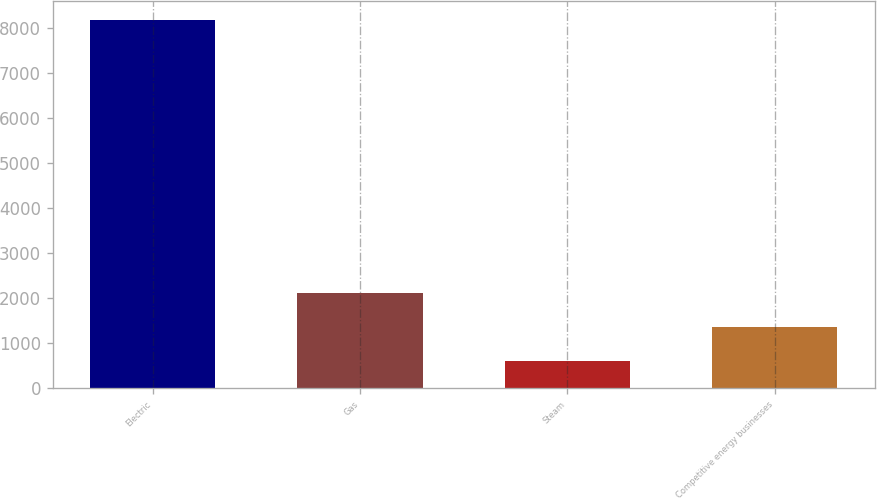<chart> <loc_0><loc_0><loc_500><loc_500><bar_chart><fcel>Electric<fcel>Gas<fcel>Steam<fcel>Competitive energy businesses<nl><fcel>8176<fcel>2112<fcel>596<fcel>1354<nl></chart> 